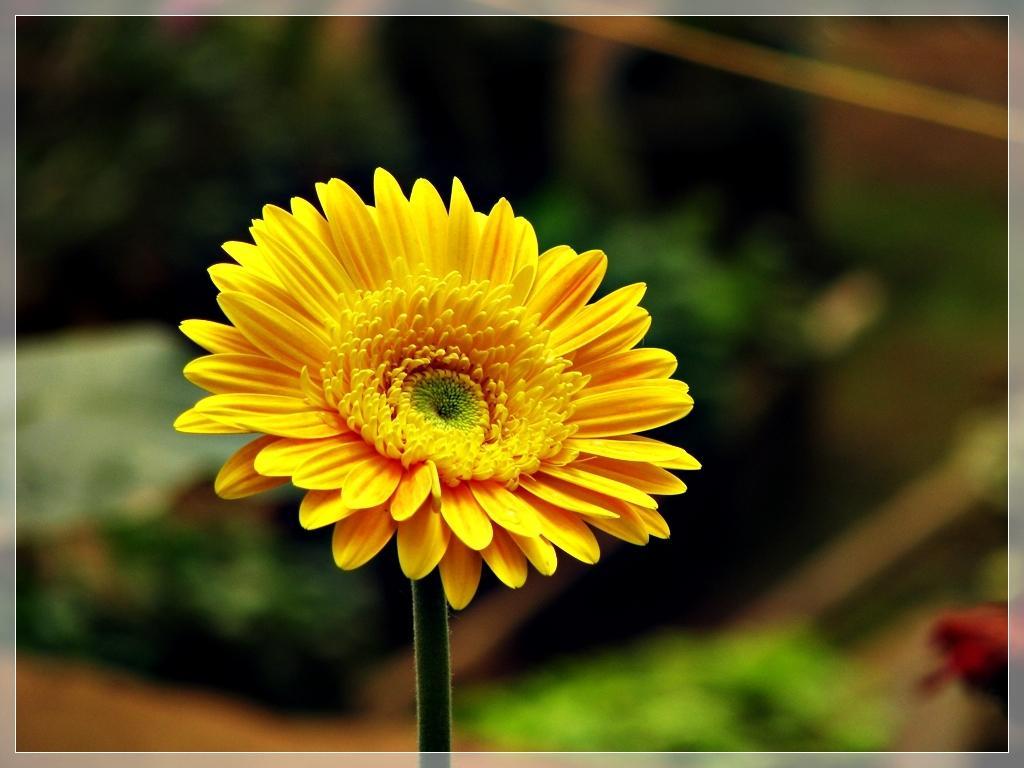Describe this image in one or two sentences. In this image there is a sunflower to a stem. Behind it there are plants. The background is blurry. There is a border around the image. 